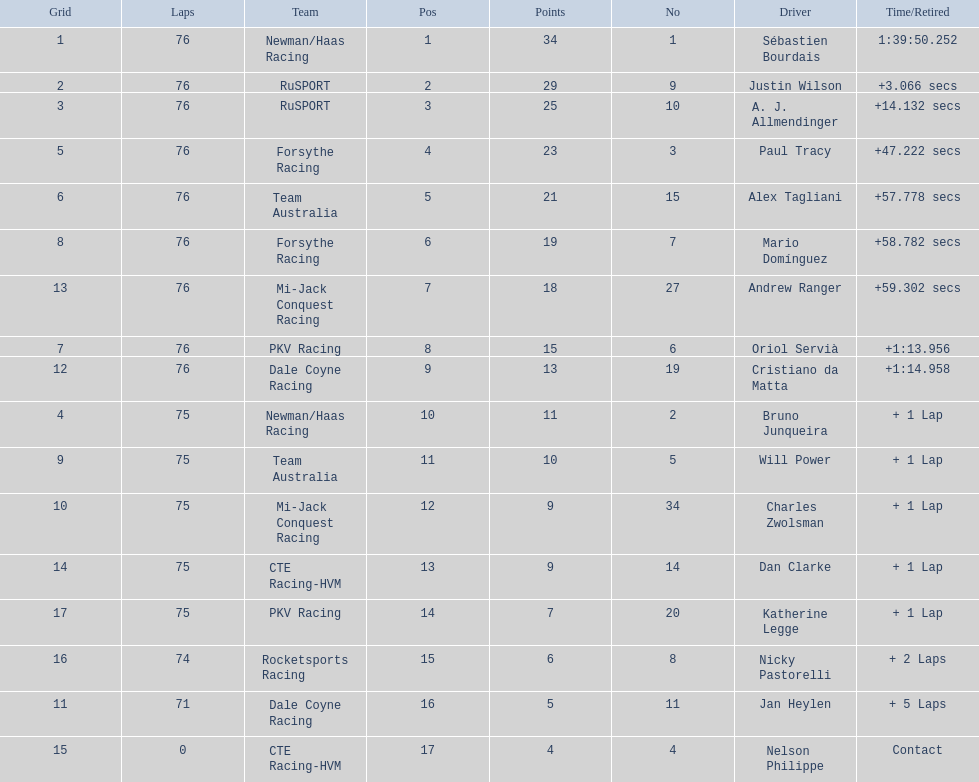Which driver has the least amount of points? Nelson Philippe. 